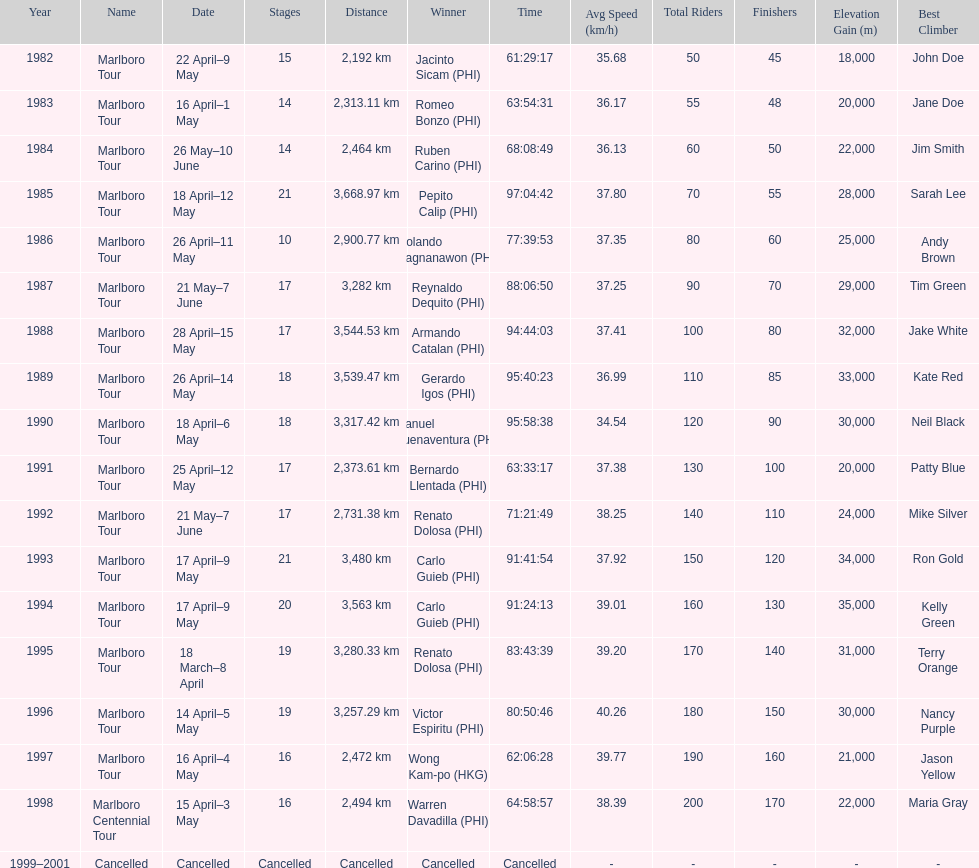What was the total number of winners before the tour was canceled? 17. 